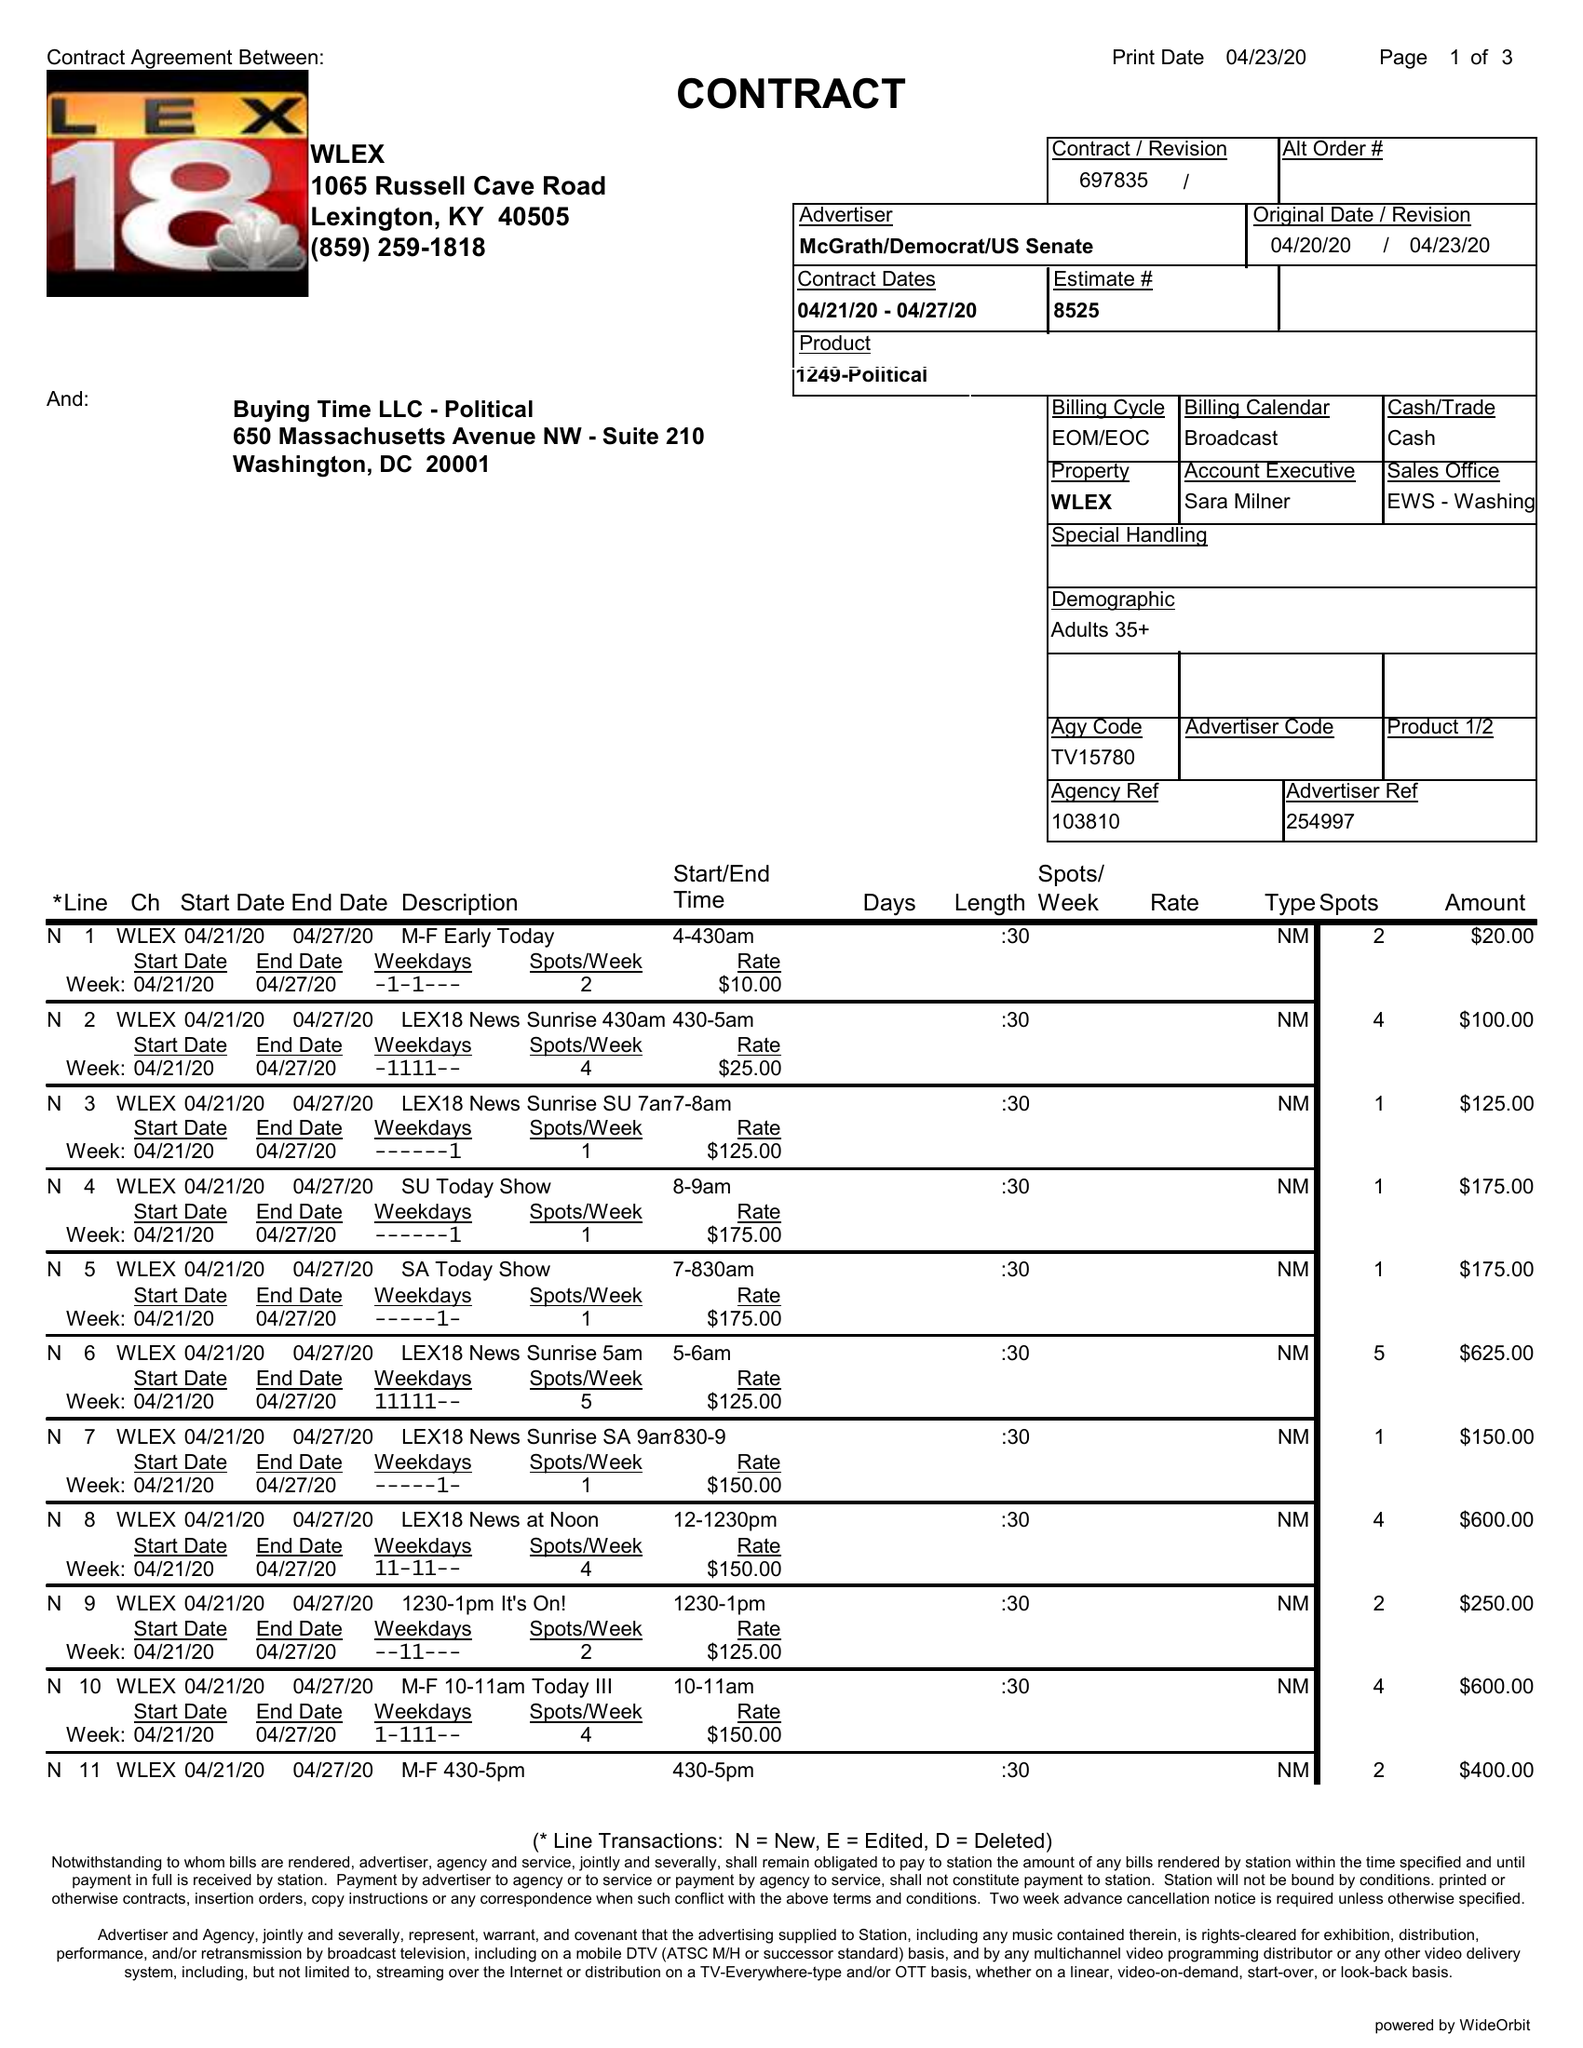What is the value for the gross_amount?
Answer the question using a single word or phrase. 9820.00 